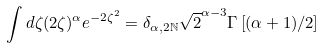<formula> <loc_0><loc_0><loc_500><loc_500>\int d \zeta ( 2 \zeta ) ^ { \alpha } e ^ { - 2 \zeta ^ { 2 } } = \delta _ { \alpha , 2 \mathbb { N } } \sqrt { 2 } ^ { \alpha - 3 } \Gamma \left [ ( \alpha + 1 ) / 2 \right ]</formula> 